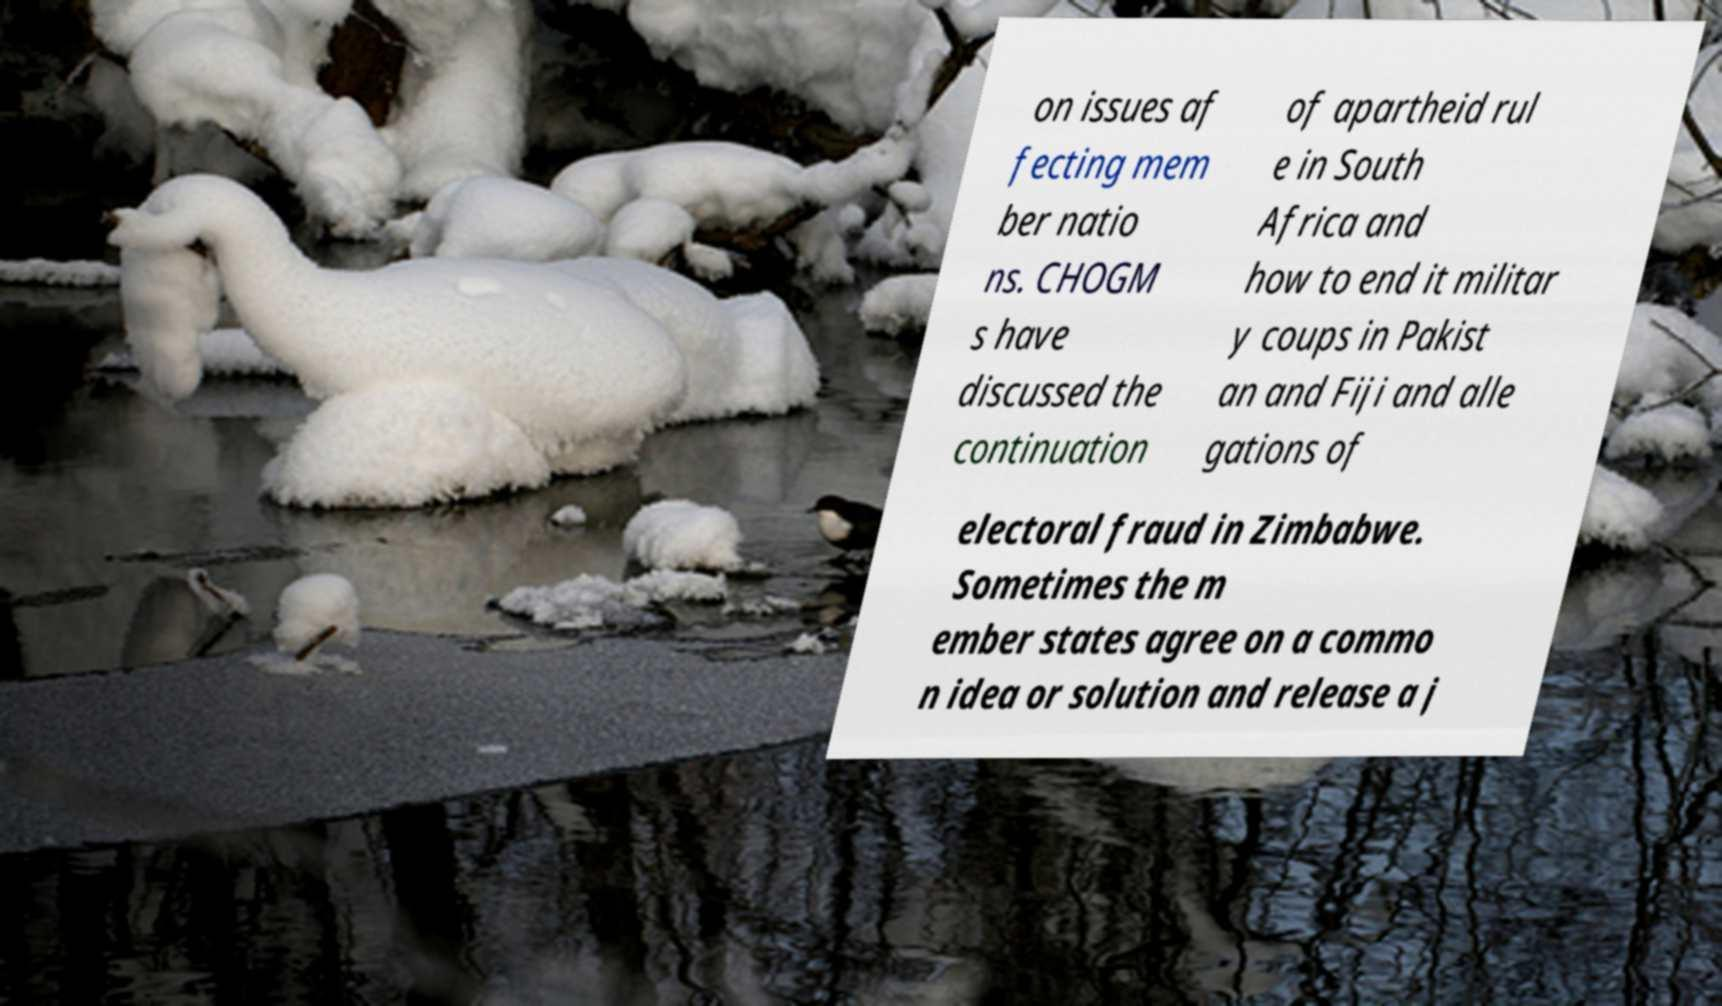Could you extract and type out the text from this image? on issues af fecting mem ber natio ns. CHOGM s have discussed the continuation of apartheid rul e in South Africa and how to end it militar y coups in Pakist an and Fiji and alle gations of electoral fraud in Zimbabwe. Sometimes the m ember states agree on a commo n idea or solution and release a j 